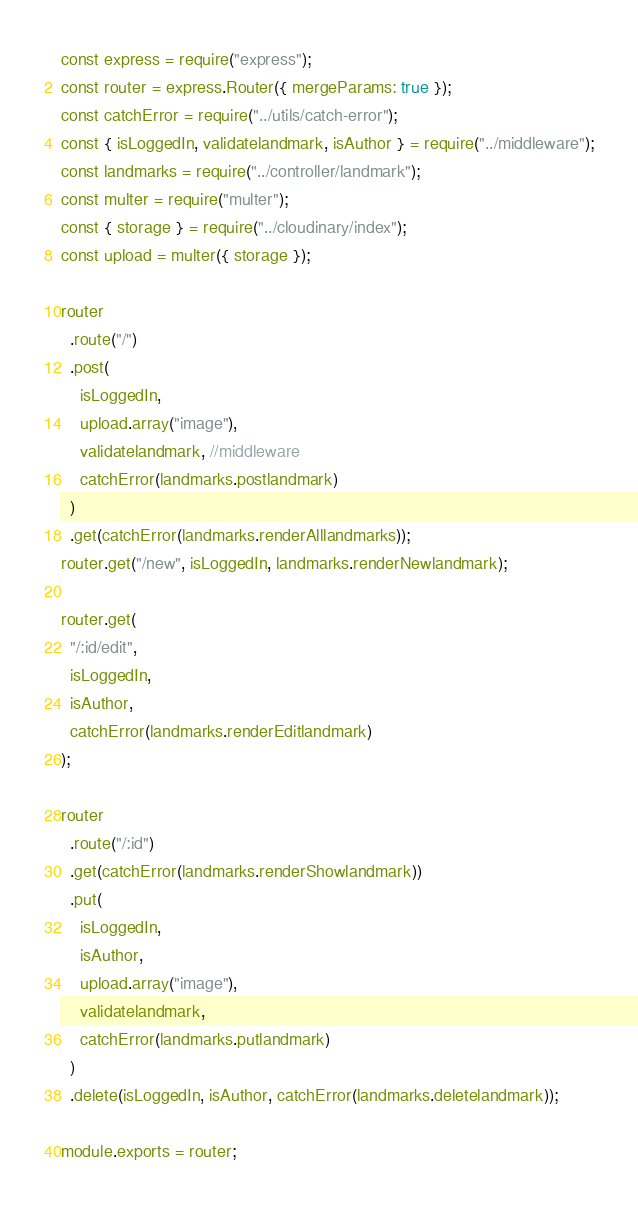Convert code to text. <code><loc_0><loc_0><loc_500><loc_500><_JavaScript_>const express = require("express");
const router = express.Router({ mergeParams: true });
const catchError = require("../utils/catch-error");
const { isLoggedIn, validatelandmark, isAuthor } = require("../middleware");
const landmarks = require("../controller/landmark");
const multer = require("multer");
const { storage } = require("../cloudinary/index");
const upload = multer({ storage });

router
  .route("/")
  .post(
    isLoggedIn,
    upload.array("image"),
    validatelandmark, //middleware
    catchError(landmarks.postlandmark)
  )
  .get(catchError(landmarks.renderAlllandmarks));
router.get("/new", isLoggedIn, landmarks.renderNewlandmark);

router.get(
  "/:id/edit",
  isLoggedIn,
  isAuthor,
  catchError(landmarks.renderEditlandmark)
);

router
  .route("/:id")
  .get(catchError(landmarks.renderShowlandmark))
  .put(
    isLoggedIn,
    isAuthor,
    upload.array("image"),
    validatelandmark,
    catchError(landmarks.putlandmark)
  )
  .delete(isLoggedIn, isAuthor, catchError(landmarks.deletelandmark));

module.exports = router;
</code> 